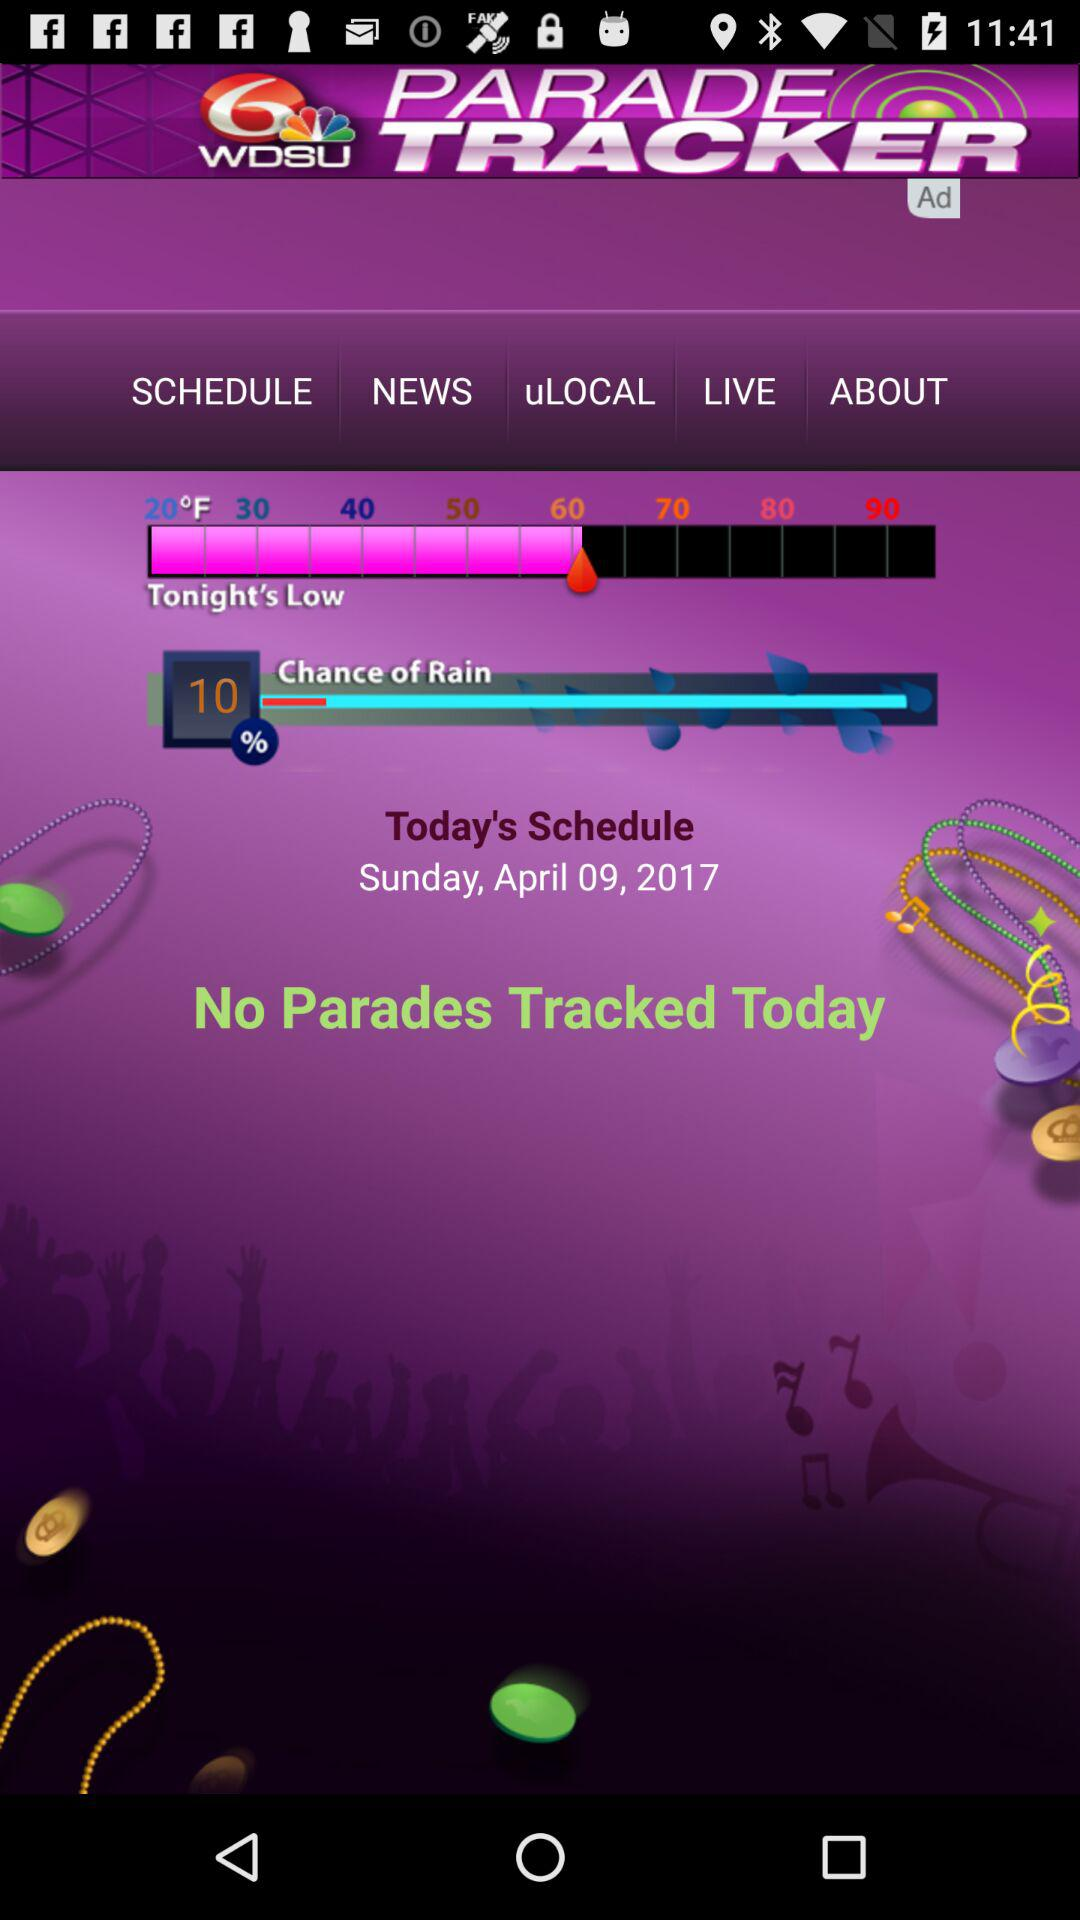Are there any parades tracked today? There are no parades tracked today. 